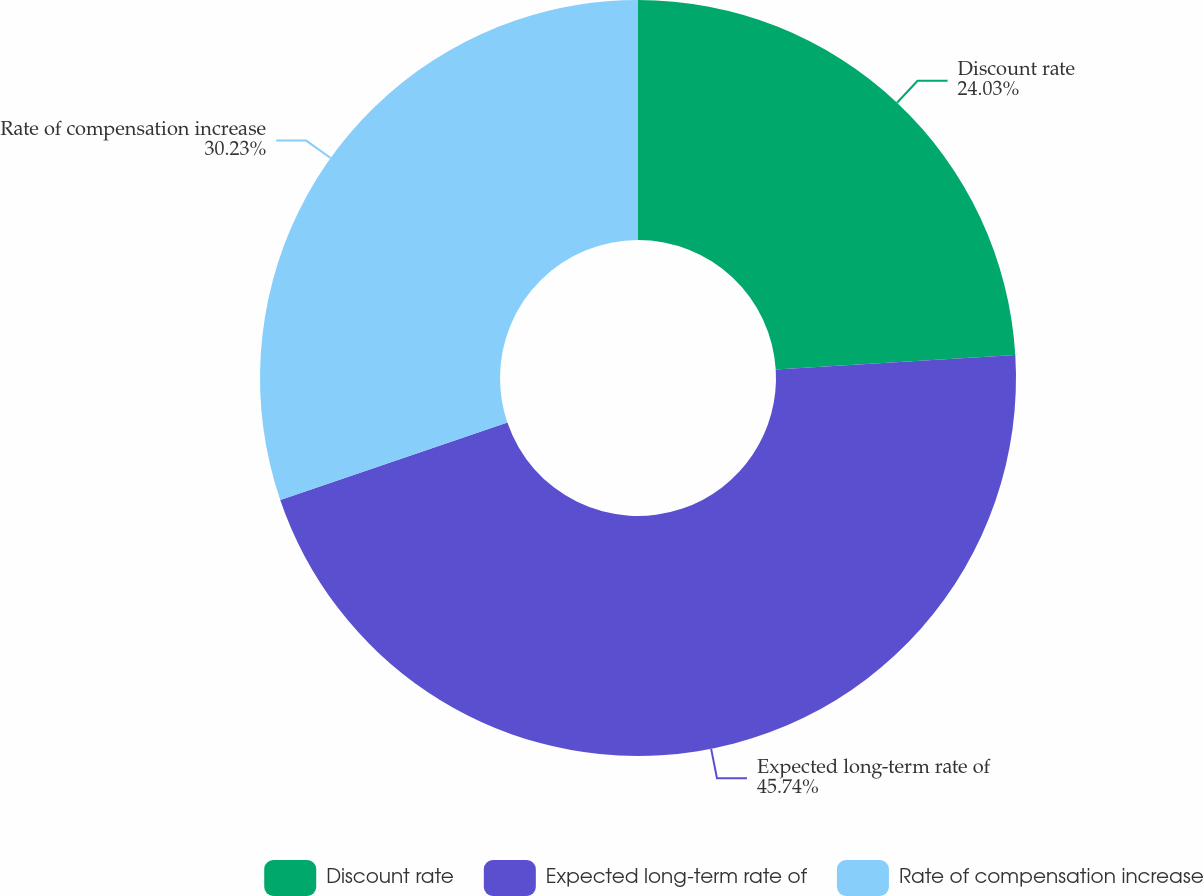Convert chart. <chart><loc_0><loc_0><loc_500><loc_500><pie_chart><fcel>Discount rate<fcel>Expected long-term rate of<fcel>Rate of compensation increase<nl><fcel>24.03%<fcel>45.74%<fcel>30.23%<nl></chart> 